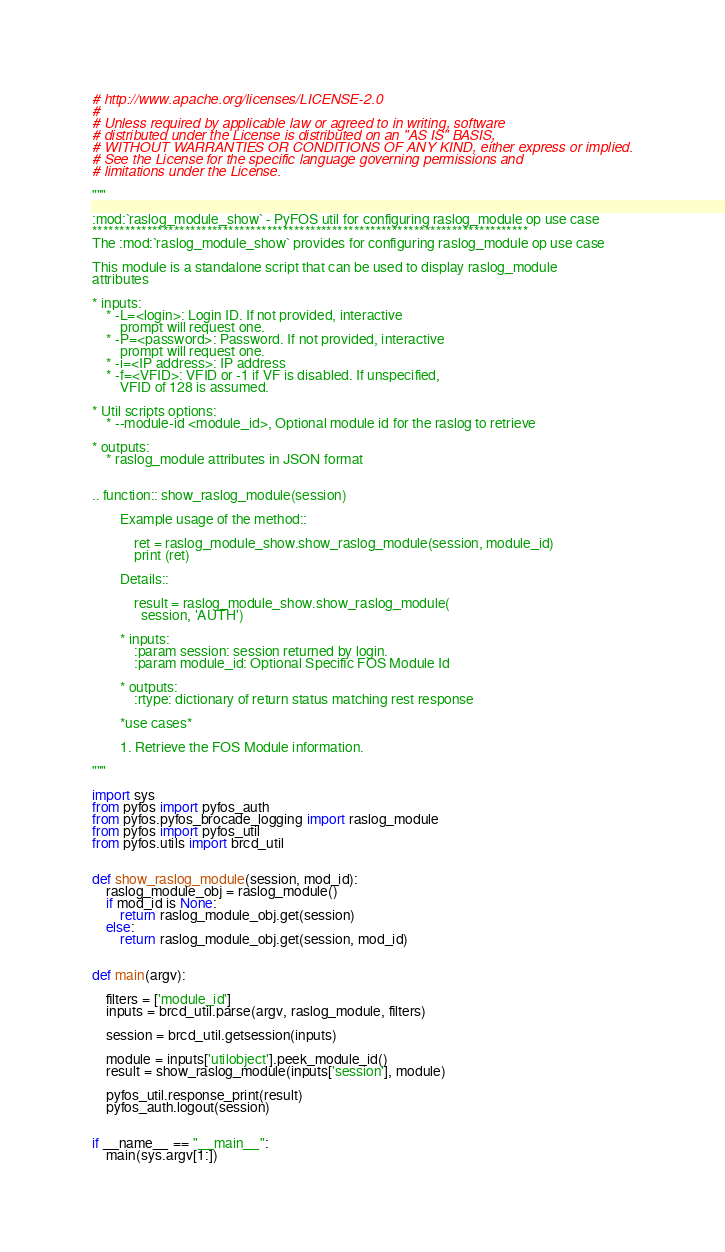Convert code to text. <code><loc_0><loc_0><loc_500><loc_500><_Python_># http://www.apache.org/licenses/LICENSE-2.0
#
# Unless required by applicable law or agreed to in writing, software
# distributed under the License is distributed on an "AS IS" BASIS,
# WITHOUT WARRANTIES OR CONDITIONS OF ANY KIND, either express or implied.
# See the License for the specific language governing permissions and
# limitations under the License.

"""

:mod:`raslog_module_show` - PyFOS util for configuring raslog_module op use case
********************************************************************************
The :mod:`raslog_module_show` provides for configuring raslog_module op use case

This module is a standalone script that can be used to display raslog_module
attributes

* inputs:
    * -L=<login>: Login ID. If not provided, interactive
        prompt will request one.
    * -P=<password>: Password. If not provided, interactive
        prompt will request one.
    * -i=<IP address>: IP address
    * -f=<VFID>: VFID or -1 if VF is disabled. If unspecified,
        VFID of 128 is assumed.

* Util scripts options:
    * --module-id <module_id>, Optional module id for the raslog to retrieve

* outputs:
    * raslog_module attributes in JSON format


.. function:: show_raslog_module(session)

        Example usage of the method::

            ret = raslog_module_show.show_raslog_module(session, module_id)
            print (ret)

        Details::

            result = raslog_module_show.show_raslog_module(
              session, 'AUTH')

        * inputs:
            :param session: session returned by login.
            :param module_id: Optional Specific FOS Module Id

        * outputs:
            :rtype: dictionary of return status matching rest response

        *use cases*

        1. Retrieve the FOS Module information.

"""

import sys
from pyfos import pyfos_auth
from pyfos.pyfos_brocade_logging import raslog_module
from pyfos import pyfos_util
from pyfos.utils import brcd_util


def show_raslog_module(session, mod_id):
    raslog_module_obj = raslog_module()
    if mod_id is None:
        return raslog_module_obj.get(session)
    else:
        return raslog_module_obj.get(session, mod_id)


def main(argv):

    filters = ['module_id']
    inputs = brcd_util.parse(argv, raslog_module, filters)

    session = brcd_util.getsession(inputs)

    module = inputs['utilobject'].peek_module_id()
    result = show_raslog_module(inputs['session'], module)

    pyfos_util.response_print(result)
    pyfos_auth.logout(session)


if __name__ == "__main__":
    main(sys.argv[1:])
</code> 